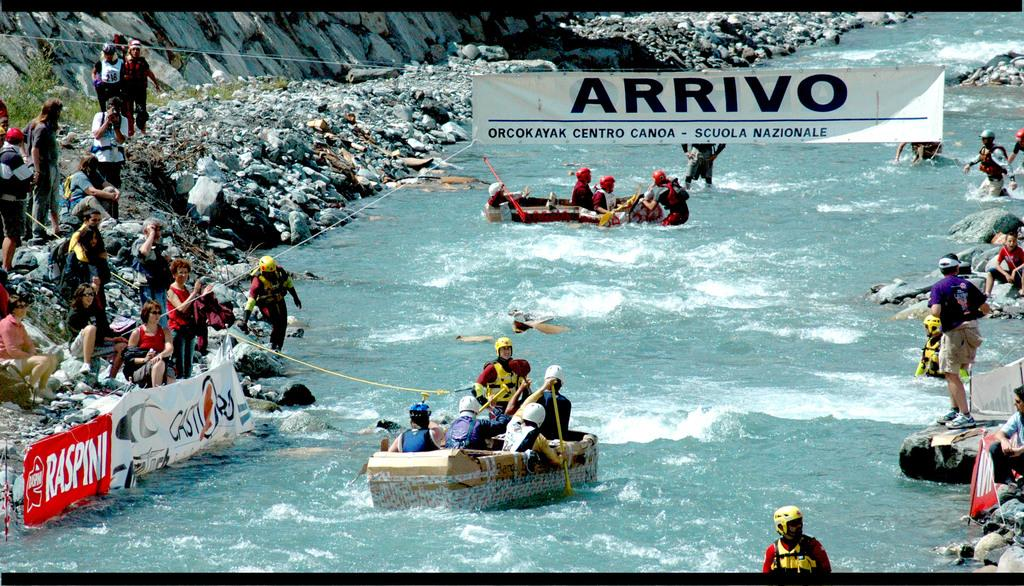What are the people doing in the image? The people are kayaking on boats in the image. Where are the boats located? The boats are in a canal. What can be seen on either side of the canal? There are people standing on rocky land on either side of the canal. What is hanging above the scene? There is a banner visible above the scene. Who is the owner of the wood in the image? A: There is no wood present in the image, so it is not possible to determine the owner. 